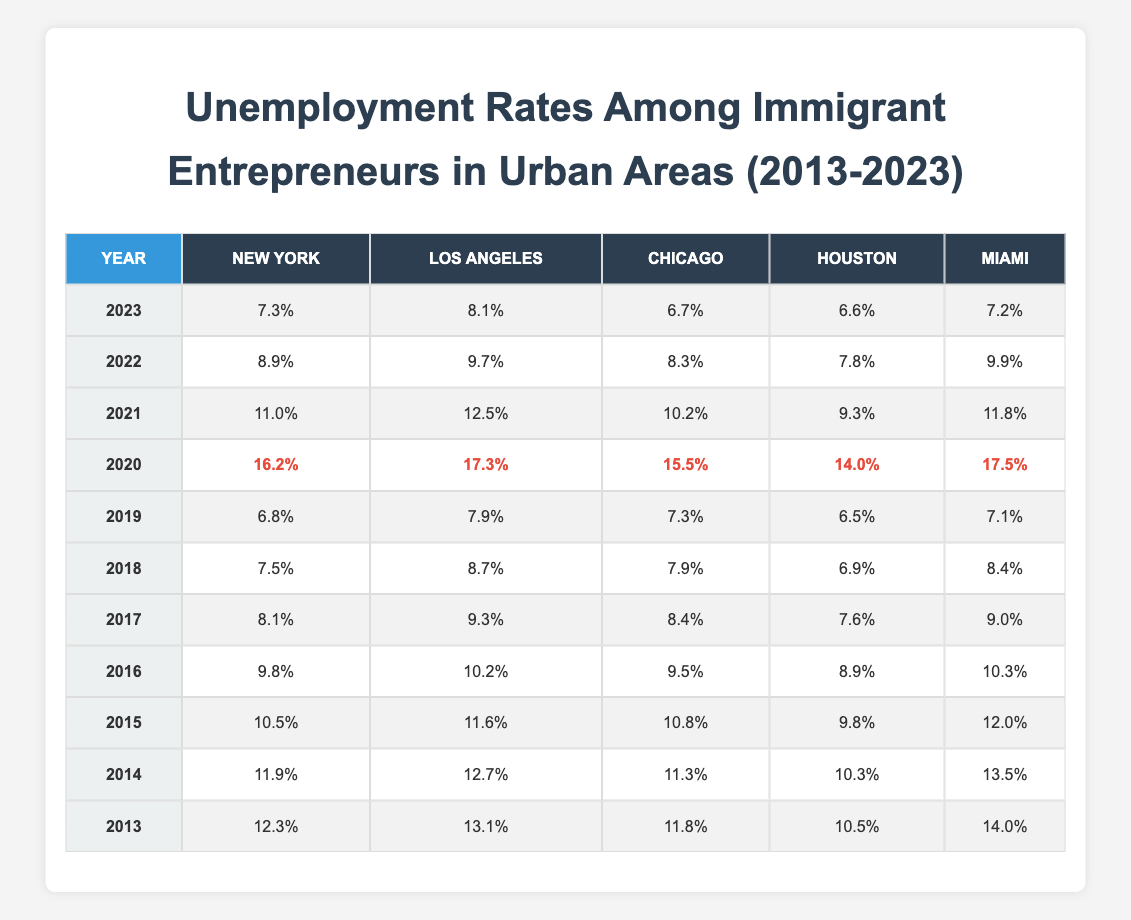What was the highest unemployment rate for immigrant entrepreneurs in New York during the past decade? The highest unemployment rate in New York was 16.2%, which occurred in 2020. This is the maximum value found in the New York column across the years presented in the table.
Answer: 16.2% Which city had the lowest unemployment rate in 2019? In 2019, Houston had the lowest unemployment rate at 6.5%. By comparing the unemployment rates across all cities for that year, Houston’s figure was the smallest.
Answer: 6.5% What is the average unemployment rate for immigrant entrepreneurs in Chicago from 2013 to 2019? To find the average, we sum the unemployment rates for Chicago from 2013 (11.8), 2014 (11.3), 2015 (10.8), 2016 (9.5), 2017 (8.4), 2018 (7.9), and 2019 (7.3), which totals 69.0. Dividing this sum by the number of years (7) gives us an average of 69.0 / 7 = 9.86.
Answer: 9.86 Did the unemployment rate in Miami drop below 10% at any point between 2013 and 2023? Yes, the unemployment rate in Miami dropped below 10% in the years 2018 (8.4%) and 2019 (7.1%). By examining the data for those specific years, we see that both values are less than 10%.
Answer: Yes What was the change in the unemployment rate for immigrant entrepreneurs from 2020 to 2021 in Los Angeles? The unemployment rate in Los Angeles in 2020 was 17.3%, and it decreased to 12.5% in 2021. The change is calculated as 17.3 - 12.5 = 4.8, indicating a decrease of 4.8%.
Answer: 4.8% 